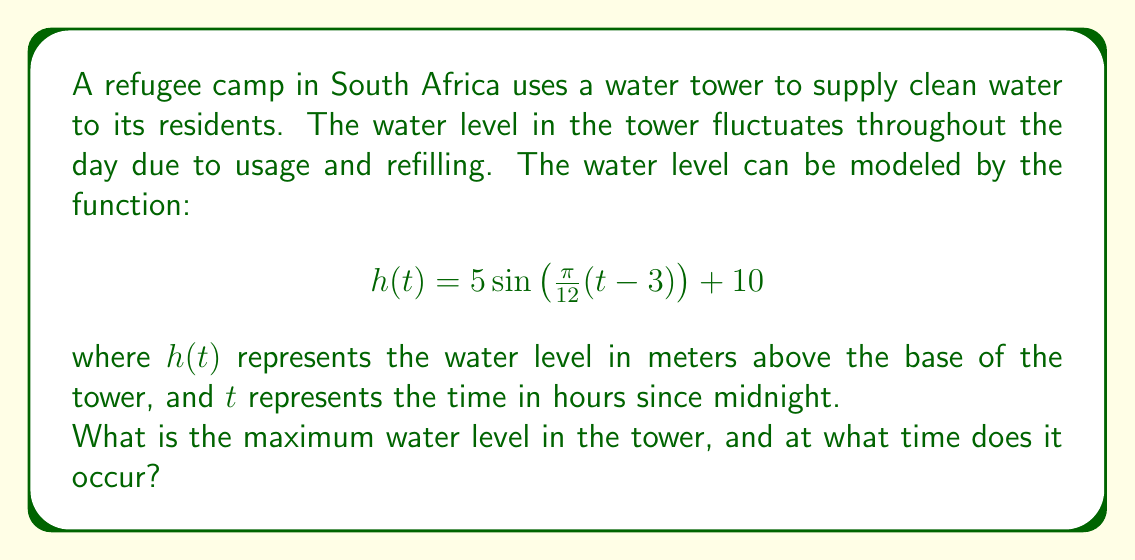What is the answer to this math problem? Let's analyze this function step-by-step:

1) The general form of a sine function is:
   $$f(t) = A\sin(B(t-C)) + D$$
   where:
   - $A$ is the amplitude
   - $B$ is the frequency
   - $C$ is the phase shift
   - $D$ is the vertical shift

2) In our function:
   $$h(t) = 5\sin\left(\frac{\pi}{12}(t-3)\right) + 10$$
   We can identify:
   - $A = 5$ (amplitude)
   - $B = \frac{\pi}{12}$ (frequency)
   - $C = 3$ (phase shift)
   - $D = 10$ (vertical shift)

3) The maximum value of $\sin(x)$ is always 1, which occurs when the angle inside the sine function is $\frac{\pi}{2}$ (or 90°).

4) The maximum water level will occur when:
   $$5\sin\left(\frac{\pi}{12}(t-3)\right) = 5$$

5) This happens when:
   $$\frac{\pi}{12}(t-3) = \frac{\pi}{2}$$

6) Solving for $t$:
   $$t-3 = 6$$
   $$t = 9$$

7) The maximum water level is:
   $$h(9) = 5\sin\left(\frac{\pi}{12}(9-3)\right) + 10 = 5 + 10 = 15$$

Therefore, the maximum water level is 15 meters, occurring at 9:00 AM (9 hours after midnight).
Answer: 15 meters at 9:00 AM 